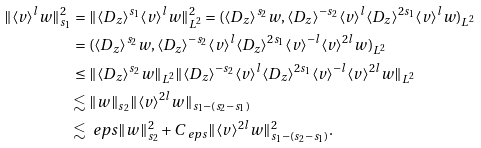Convert formula to latex. <formula><loc_0><loc_0><loc_500><loc_500>\| \langle v \rangle ^ { l } w \| _ { s _ { 1 } } ^ { 2 } = & \ \| \langle D _ { z } \rangle ^ { s _ { 1 } } \langle v \rangle ^ { l } w \| _ { L ^ { 2 } } ^ { 2 } = ( \langle D _ { z } \rangle ^ { s _ { 2 } } w , \langle D _ { z } \rangle ^ { - s _ { 2 } } \langle v \rangle ^ { l } \langle D _ { z } \rangle ^ { 2 s _ { 1 } } \langle v \rangle ^ { l } w ) _ { L ^ { 2 } } \\ = & \ ( \langle D _ { z } \rangle ^ { s _ { 2 } } w , \langle D _ { z } \rangle ^ { - s _ { 2 } } \langle v \rangle ^ { l } \langle D _ { z } \rangle ^ { 2 s _ { 1 } } \langle v \rangle ^ { - l } \langle v \rangle ^ { 2 l } w ) _ { L ^ { 2 } } \\ \leq & \ \| \langle D _ { z } \rangle ^ { s _ { 2 } } w \| _ { L ^ { 2 } } \| \langle D _ { z } \rangle ^ { - s _ { 2 } } \langle v \rangle ^ { l } \langle D _ { z } \rangle ^ { 2 s _ { 1 } } \langle v \rangle ^ { - l } \langle v \rangle ^ { 2 l } w \| _ { L ^ { 2 } } \\ \lesssim & \ \| w \| _ { s _ { 2 } } \| \langle v \rangle ^ { 2 l } w \| _ { s _ { 1 } - ( s _ { 2 } - s _ { 1 } ) } \\ \lesssim & \ \ e p s \| w \| _ { s _ { 2 } } ^ { 2 } + C _ { \ e p s } \| \langle v \rangle ^ { 2 l } w \| _ { s _ { 1 } - ( s _ { 2 } - s _ { 1 } ) } ^ { 2 } .</formula> 